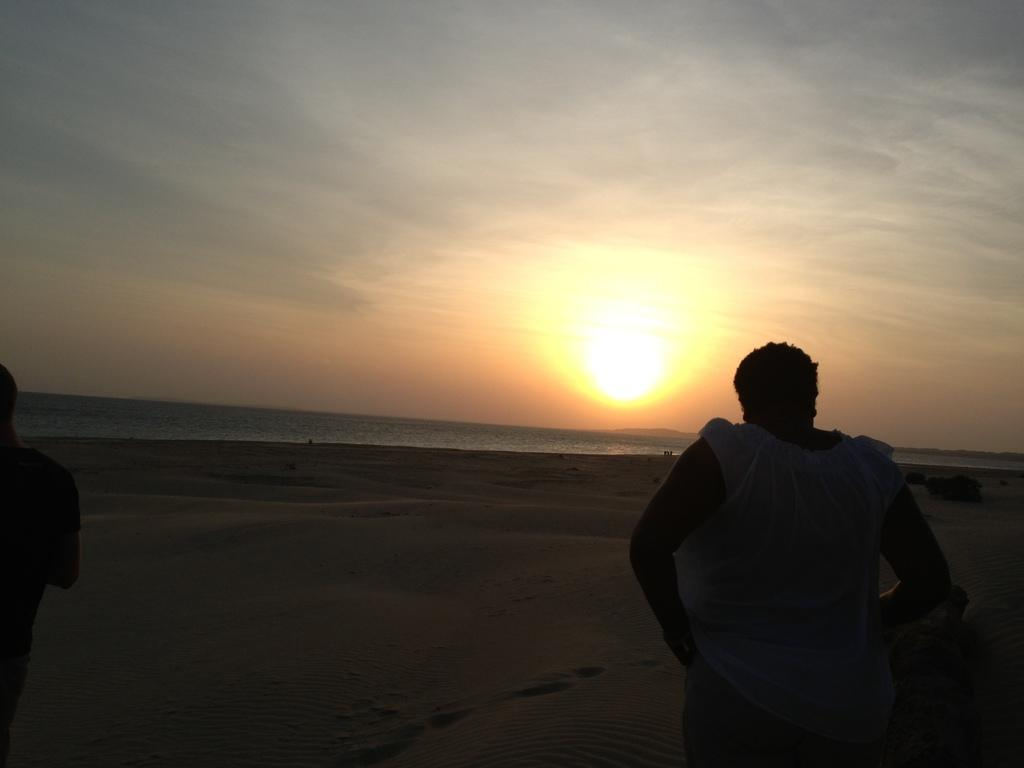How many people are in the foreground of the image? There are two persons in the foreground of the image. What is visible in the background of the image? There is an ocean in the background of the image. What can be seen in the sky in the image? The sky is visible in the image, and the sun is visible in the sky. What type of location is depicted in the image? The image was taken on a sandy beach. What color is the underwear of the person on the left in the image? There is no information about the underwear of the person on the left in the image, as it is not visible or mentioned in the provided facts. 